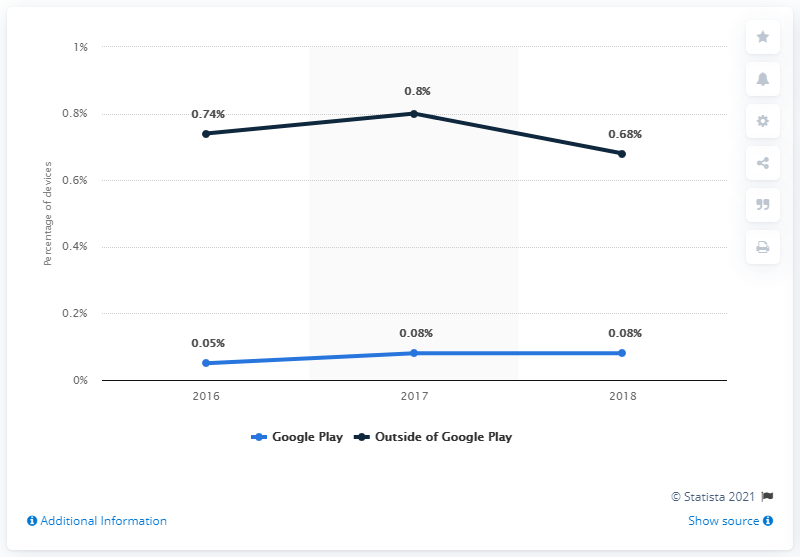Outline some significant characteristics in this image. In 2017, the usage of terms related to "outside of Google Play" reached its peak. In 2018, less than 1% of Android devices that installed apps only from Google Play were affected by potentially harmful apps. The infection rate of Android devices that installed apps outside of Google Play was 0.68%. The average of "Google Play" is 0.07. 